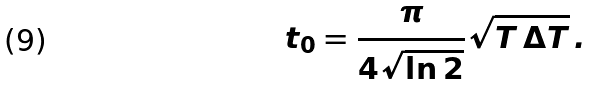Convert formula to latex. <formula><loc_0><loc_0><loc_500><loc_500>t _ { 0 } = \frac { \pi } { 4 \sqrt { \ln 2 } } \sqrt { T \, \Delta T } \, .</formula> 